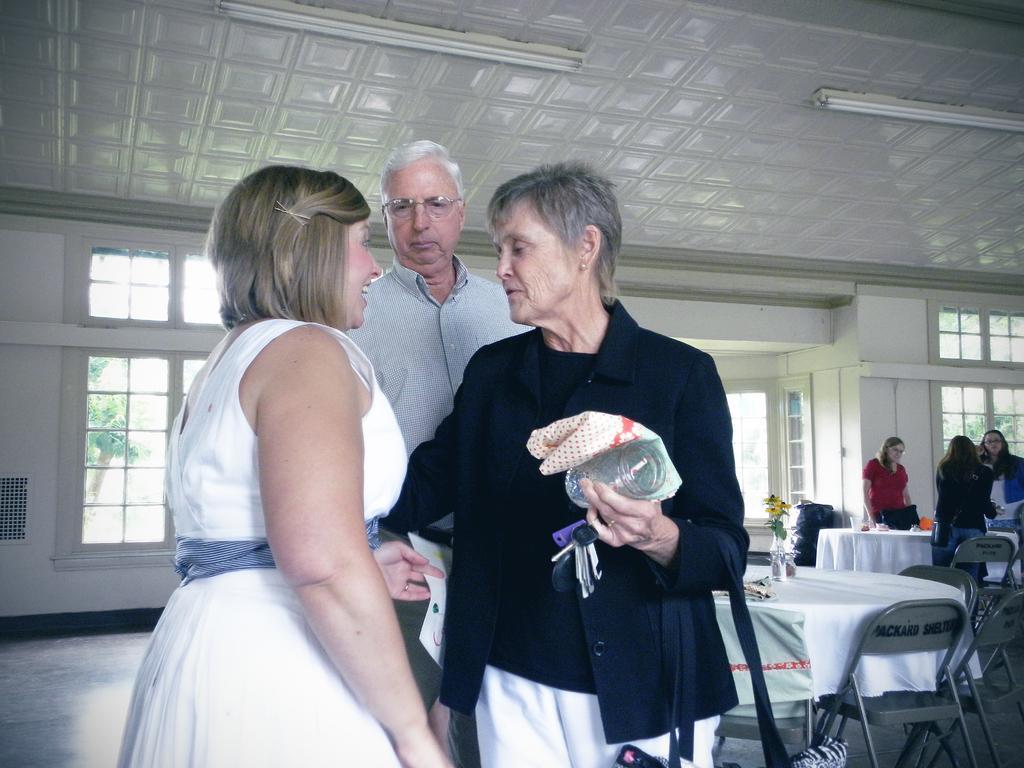How would you summarize this image in a sentence or two? This picture is clicked inside the hall. In the foreground we can see a person wearing black color blazer, holding some objects and seems to be standing. On the left we can see a woman wearing white color dress, smiling and standing and we can see a person wearing shirt and standing on the ground. In the background we can see the tables, chairs, flower vase and we can see the wall, windows, roof, lights and some other items. In the right corner we can see the group of people standing on the ground and in the background through the windows we can see the outside view. 